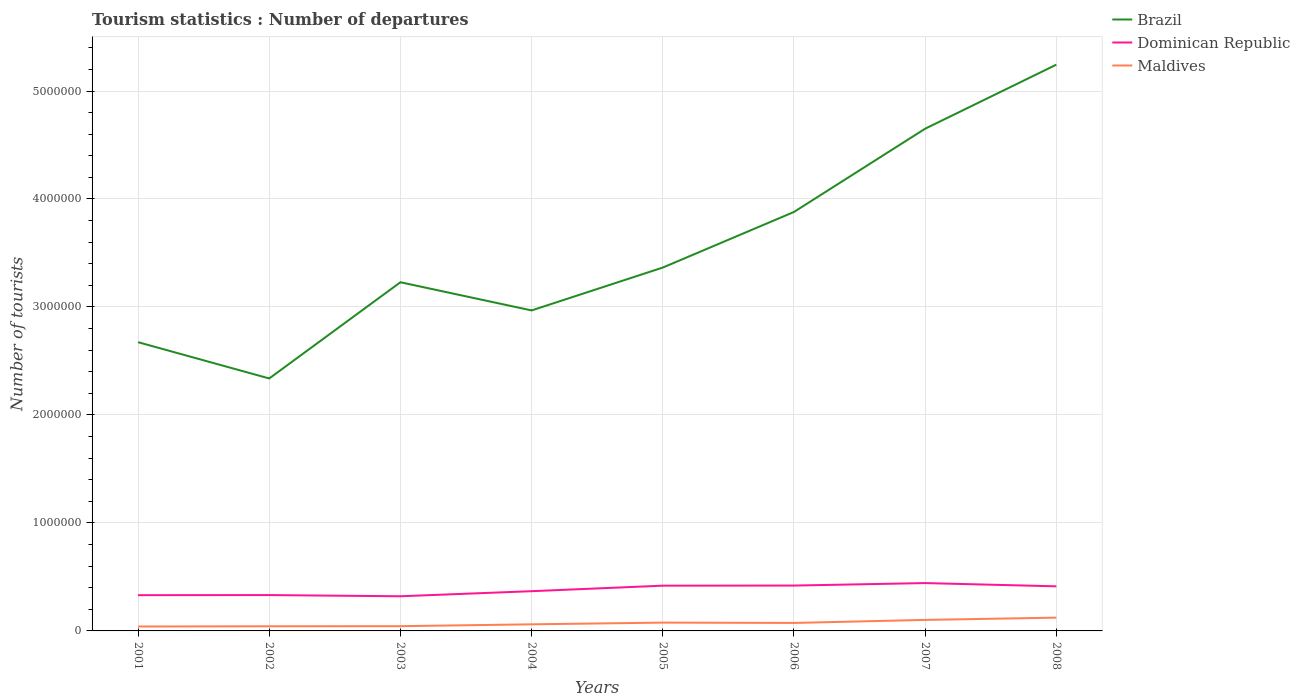Across all years, what is the maximum number of tourist departures in Brazil?
Make the answer very short. 2.34e+06. What is the total number of tourist departures in Maldives in the graph?
Offer a terse response. -5.80e+04. What is the difference between the highest and the second highest number of tourist departures in Dominican Republic?
Offer a terse response. 1.22e+05. What is the difference between the highest and the lowest number of tourist departures in Dominican Republic?
Offer a very short reply. 4. How many lines are there?
Offer a terse response. 3. How many years are there in the graph?
Your answer should be very brief. 8. Where does the legend appear in the graph?
Make the answer very short. Top right. How many legend labels are there?
Keep it short and to the point. 3. What is the title of the graph?
Your response must be concise. Tourism statistics : Number of departures. Does "Mozambique" appear as one of the legend labels in the graph?
Your answer should be compact. No. What is the label or title of the X-axis?
Your answer should be very brief. Years. What is the label or title of the Y-axis?
Give a very brief answer. Number of tourists. What is the Number of tourists in Brazil in 2001?
Offer a very short reply. 2.67e+06. What is the Number of tourists of Dominican Republic in 2001?
Ensure brevity in your answer.  3.31e+05. What is the Number of tourists in Maldives in 2001?
Make the answer very short. 4.10e+04. What is the Number of tourists in Brazil in 2002?
Your answer should be very brief. 2.34e+06. What is the Number of tourists in Dominican Republic in 2002?
Make the answer very short. 3.32e+05. What is the Number of tourists of Maldives in 2002?
Make the answer very short. 4.30e+04. What is the Number of tourists in Brazil in 2003?
Your response must be concise. 3.23e+06. What is the Number of tourists in Dominican Republic in 2003?
Offer a very short reply. 3.21e+05. What is the Number of tourists of Maldives in 2003?
Offer a terse response. 4.40e+04. What is the Number of tourists in Brazil in 2004?
Offer a terse response. 2.97e+06. What is the Number of tourists in Dominican Republic in 2004?
Your answer should be very brief. 3.68e+05. What is the Number of tourists in Maldives in 2004?
Provide a short and direct response. 6.10e+04. What is the Number of tourists of Brazil in 2005?
Your answer should be compact. 3.36e+06. What is the Number of tourists of Dominican Republic in 2005?
Your response must be concise. 4.19e+05. What is the Number of tourists in Maldives in 2005?
Offer a terse response. 7.70e+04. What is the Number of tourists in Brazil in 2006?
Offer a very short reply. 3.88e+06. What is the Number of tourists of Dominican Republic in 2006?
Make the answer very short. 4.20e+05. What is the Number of tourists of Maldives in 2006?
Keep it short and to the point. 7.40e+04. What is the Number of tourists in Brazil in 2007?
Ensure brevity in your answer.  4.65e+06. What is the Number of tourists in Dominican Republic in 2007?
Offer a very short reply. 4.43e+05. What is the Number of tourists of Maldives in 2007?
Offer a very short reply. 1.02e+05. What is the Number of tourists in Brazil in 2008?
Your answer should be compact. 5.24e+06. What is the Number of tourists of Dominican Republic in 2008?
Ensure brevity in your answer.  4.13e+05. What is the Number of tourists in Maldives in 2008?
Provide a succinct answer. 1.23e+05. Across all years, what is the maximum Number of tourists of Brazil?
Offer a terse response. 5.24e+06. Across all years, what is the maximum Number of tourists of Dominican Republic?
Your answer should be compact. 4.43e+05. Across all years, what is the maximum Number of tourists of Maldives?
Make the answer very short. 1.23e+05. Across all years, what is the minimum Number of tourists of Brazil?
Keep it short and to the point. 2.34e+06. Across all years, what is the minimum Number of tourists of Dominican Republic?
Make the answer very short. 3.21e+05. Across all years, what is the minimum Number of tourists of Maldives?
Offer a terse response. 4.10e+04. What is the total Number of tourists in Brazil in the graph?
Ensure brevity in your answer.  2.83e+07. What is the total Number of tourists of Dominican Republic in the graph?
Ensure brevity in your answer.  3.05e+06. What is the total Number of tourists of Maldives in the graph?
Your answer should be compact. 5.65e+05. What is the difference between the Number of tourists in Brazil in 2001 and that in 2002?
Ensure brevity in your answer.  3.36e+05. What is the difference between the Number of tourists in Dominican Republic in 2001 and that in 2002?
Give a very brief answer. -1000. What is the difference between the Number of tourists of Maldives in 2001 and that in 2002?
Ensure brevity in your answer.  -2000. What is the difference between the Number of tourists in Brazil in 2001 and that in 2003?
Keep it short and to the point. -5.55e+05. What is the difference between the Number of tourists of Dominican Republic in 2001 and that in 2003?
Provide a succinct answer. 10000. What is the difference between the Number of tourists of Maldives in 2001 and that in 2003?
Offer a very short reply. -3000. What is the difference between the Number of tourists of Brazil in 2001 and that in 2004?
Ensure brevity in your answer.  -2.94e+05. What is the difference between the Number of tourists in Dominican Republic in 2001 and that in 2004?
Your answer should be compact. -3.70e+04. What is the difference between the Number of tourists in Maldives in 2001 and that in 2004?
Keep it short and to the point. -2.00e+04. What is the difference between the Number of tourists in Brazil in 2001 and that in 2005?
Your answer should be very brief. -6.91e+05. What is the difference between the Number of tourists of Dominican Republic in 2001 and that in 2005?
Provide a short and direct response. -8.80e+04. What is the difference between the Number of tourists of Maldives in 2001 and that in 2005?
Provide a short and direct response. -3.60e+04. What is the difference between the Number of tourists in Brazil in 2001 and that in 2006?
Ensure brevity in your answer.  -1.21e+06. What is the difference between the Number of tourists in Dominican Republic in 2001 and that in 2006?
Offer a very short reply. -8.90e+04. What is the difference between the Number of tourists in Maldives in 2001 and that in 2006?
Your answer should be compact. -3.30e+04. What is the difference between the Number of tourists of Brazil in 2001 and that in 2007?
Make the answer very short. -1.98e+06. What is the difference between the Number of tourists of Dominican Republic in 2001 and that in 2007?
Your answer should be very brief. -1.12e+05. What is the difference between the Number of tourists of Maldives in 2001 and that in 2007?
Provide a succinct answer. -6.10e+04. What is the difference between the Number of tourists of Brazil in 2001 and that in 2008?
Provide a short and direct response. -2.57e+06. What is the difference between the Number of tourists of Dominican Republic in 2001 and that in 2008?
Make the answer very short. -8.20e+04. What is the difference between the Number of tourists of Maldives in 2001 and that in 2008?
Your answer should be compact. -8.20e+04. What is the difference between the Number of tourists in Brazil in 2002 and that in 2003?
Give a very brief answer. -8.91e+05. What is the difference between the Number of tourists in Dominican Republic in 2002 and that in 2003?
Keep it short and to the point. 1.10e+04. What is the difference between the Number of tourists of Maldives in 2002 and that in 2003?
Provide a short and direct response. -1000. What is the difference between the Number of tourists of Brazil in 2002 and that in 2004?
Provide a short and direct response. -6.30e+05. What is the difference between the Number of tourists in Dominican Republic in 2002 and that in 2004?
Your answer should be very brief. -3.60e+04. What is the difference between the Number of tourists in Maldives in 2002 and that in 2004?
Your response must be concise. -1.80e+04. What is the difference between the Number of tourists in Brazil in 2002 and that in 2005?
Make the answer very short. -1.03e+06. What is the difference between the Number of tourists in Dominican Republic in 2002 and that in 2005?
Provide a succinct answer. -8.70e+04. What is the difference between the Number of tourists in Maldives in 2002 and that in 2005?
Provide a succinct answer. -3.40e+04. What is the difference between the Number of tourists in Brazil in 2002 and that in 2006?
Provide a succinct answer. -1.54e+06. What is the difference between the Number of tourists in Dominican Republic in 2002 and that in 2006?
Your answer should be compact. -8.80e+04. What is the difference between the Number of tourists in Maldives in 2002 and that in 2006?
Keep it short and to the point. -3.10e+04. What is the difference between the Number of tourists of Brazil in 2002 and that in 2007?
Your answer should be very brief. -2.31e+06. What is the difference between the Number of tourists in Dominican Republic in 2002 and that in 2007?
Keep it short and to the point. -1.11e+05. What is the difference between the Number of tourists in Maldives in 2002 and that in 2007?
Offer a terse response. -5.90e+04. What is the difference between the Number of tourists in Brazil in 2002 and that in 2008?
Your answer should be very brief. -2.91e+06. What is the difference between the Number of tourists of Dominican Republic in 2002 and that in 2008?
Offer a very short reply. -8.10e+04. What is the difference between the Number of tourists of Maldives in 2002 and that in 2008?
Your answer should be very brief. -8.00e+04. What is the difference between the Number of tourists in Brazil in 2003 and that in 2004?
Your answer should be compact. 2.61e+05. What is the difference between the Number of tourists of Dominican Republic in 2003 and that in 2004?
Keep it short and to the point. -4.70e+04. What is the difference between the Number of tourists of Maldives in 2003 and that in 2004?
Offer a very short reply. -1.70e+04. What is the difference between the Number of tourists in Brazil in 2003 and that in 2005?
Ensure brevity in your answer.  -1.36e+05. What is the difference between the Number of tourists in Dominican Republic in 2003 and that in 2005?
Provide a succinct answer. -9.80e+04. What is the difference between the Number of tourists of Maldives in 2003 and that in 2005?
Keep it short and to the point. -3.30e+04. What is the difference between the Number of tourists of Brazil in 2003 and that in 2006?
Your response must be concise. -6.51e+05. What is the difference between the Number of tourists in Dominican Republic in 2003 and that in 2006?
Your answer should be very brief. -9.90e+04. What is the difference between the Number of tourists in Brazil in 2003 and that in 2007?
Offer a terse response. -1.42e+06. What is the difference between the Number of tourists in Dominican Republic in 2003 and that in 2007?
Keep it short and to the point. -1.22e+05. What is the difference between the Number of tourists in Maldives in 2003 and that in 2007?
Keep it short and to the point. -5.80e+04. What is the difference between the Number of tourists in Brazil in 2003 and that in 2008?
Provide a short and direct response. -2.02e+06. What is the difference between the Number of tourists of Dominican Republic in 2003 and that in 2008?
Provide a succinct answer. -9.20e+04. What is the difference between the Number of tourists in Maldives in 2003 and that in 2008?
Keep it short and to the point. -7.90e+04. What is the difference between the Number of tourists of Brazil in 2004 and that in 2005?
Provide a succinct answer. -3.97e+05. What is the difference between the Number of tourists in Dominican Republic in 2004 and that in 2005?
Provide a succinct answer. -5.10e+04. What is the difference between the Number of tourists in Maldives in 2004 and that in 2005?
Keep it short and to the point. -1.60e+04. What is the difference between the Number of tourists in Brazil in 2004 and that in 2006?
Ensure brevity in your answer.  -9.12e+05. What is the difference between the Number of tourists in Dominican Republic in 2004 and that in 2006?
Offer a terse response. -5.20e+04. What is the difference between the Number of tourists in Maldives in 2004 and that in 2006?
Provide a short and direct response. -1.30e+04. What is the difference between the Number of tourists in Brazil in 2004 and that in 2007?
Your answer should be compact. -1.68e+06. What is the difference between the Number of tourists of Dominican Republic in 2004 and that in 2007?
Your answer should be compact. -7.50e+04. What is the difference between the Number of tourists in Maldives in 2004 and that in 2007?
Give a very brief answer. -4.10e+04. What is the difference between the Number of tourists in Brazil in 2004 and that in 2008?
Your response must be concise. -2.28e+06. What is the difference between the Number of tourists of Dominican Republic in 2004 and that in 2008?
Your response must be concise. -4.50e+04. What is the difference between the Number of tourists in Maldives in 2004 and that in 2008?
Your answer should be compact. -6.20e+04. What is the difference between the Number of tourists in Brazil in 2005 and that in 2006?
Ensure brevity in your answer.  -5.15e+05. What is the difference between the Number of tourists of Dominican Republic in 2005 and that in 2006?
Ensure brevity in your answer.  -1000. What is the difference between the Number of tourists of Maldives in 2005 and that in 2006?
Make the answer very short. 3000. What is the difference between the Number of tourists of Brazil in 2005 and that in 2007?
Offer a very short reply. -1.29e+06. What is the difference between the Number of tourists of Dominican Republic in 2005 and that in 2007?
Your answer should be compact. -2.40e+04. What is the difference between the Number of tourists of Maldives in 2005 and that in 2007?
Your answer should be very brief. -2.50e+04. What is the difference between the Number of tourists of Brazil in 2005 and that in 2008?
Offer a very short reply. -1.88e+06. What is the difference between the Number of tourists in Dominican Republic in 2005 and that in 2008?
Make the answer very short. 6000. What is the difference between the Number of tourists in Maldives in 2005 and that in 2008?
Keep it short and to the point. -4.60e+04. What is the difference between the Number of tourists of Brazil in 2006 and that in 2007?
Ensure brevity in your answer.  -7.71e+05. What is the difference between the Number of tourists of Dominican Republic in 2006 and that in 2007?
Make the answer very short. -2.30e+04. What is the difference between the Number of tourists in Maldives in 2006 and that in 2007?
Your answer should be very brief. -2.80e+04. What is the difference between the Number of tourists of Brazil in 2006 and that in 2008?
Keep it short and to the point. -1.36e+06. What is the difference between the Number of tourists in Dominican Republic in 2006 and that in 2008?
Offer a very short reply. 7000. What is the difference between the Number of tourists of Maldives in 2006 and that in 2008?
Provide a short and direct response. -4.90e+04. What is the difference between the Number of tourists in Brazil in 2007 and that in 2008?
Your answer should be compact. -5.93e+05. What is the difference between the Number of tourists in Maldives in 2007 and that in 2008?
Ensure brevity in your answer.  -2.10e+04. What is the difference between the Number of tourists of Brazil in 2001 and the Number of tourists of Dominican Republic in 2002?
Offer a very short reply. 2.34e+06. What is the difference between the Number of tourists in Brazil in 2001 and the Number of tourists in Maldives in 2002?
Ensure brevity in your answer.  2.63e+06. What is the difference between the Number of tourists in Dominican Republic in 2001 and the Number of tourists in Maldives in 2002?
Offer a very short reply. 2.88e+05. What is the difference between the Number of tourists in Brazil in 2001 and the Number of tourists in Dominican Republic in 2003?
Your response must be concise. 2.35e+06. What is the difference between the Number of tourists of Brazil in 2001 and the Number of tourists of Maldives in 2003?
Your answer should be very brief. 2.63e+06. What is the difference between the Number of tourists of Dominican Republic in 2001 and the Number of tourists of Maldives in 2003?
Offer a very short reply. 2.87e+05. What is the difference between the Number of tourists of Brazil in 2001 and the Number of tourists of Dominican Republic in 2004?
Give a very brief answer. 2.31e+06. What is the difference between the Number of tourists in Brazil in 2001 and the Number of tourists in Maldives in 2004?
Your answer should be very brief. 2.61e+06. What is the difference between the Number of tourists in Brazil in 2001 and the Number of tourists in Dominican Republic in 2005?
Your response must be concise. 2.26e+06. What is the difference between the Number of tourists in Brazil in 2001 and the Number of tourists in Maldives in 2005?
Provide a succinct answer. 2.60e+06. What is the difference between the Number of tourists in Dominican Republic in 2001 and the Number of tourists in Maldives in 2005?
Your answer should be very brief. 2.54e+05. What is the difference between the Number of tourists in Brazil in 2001 and the Number of tourists in Dominican Republic in 2006?
Make the answer very short. 2.25e+06. What is the difference between the Number of tourists in Brazil in 2001 and the Number of tourists in Maldives in 2006?
Ensure brevity in your answer.  2.60e+06. What is the difference between the Number of tourists of Dominican Republic in 2001 and the Number of tourists of Maldives in 2006?
Provide a short and direct response. 2.57e+05. What is the difference between the Number of tourists in Brazil in 2001 and the Number of tourists in Dominican Republic in 2007?
Give a very brief answer. 2.23e+06. What is the difference between the Number of tourists of Brazil in 2001 and the Number of tourists of Maldives in 2007?
Your response must be concise. 2.57e+06. What is the difference between the Number of tourists in Dominican Republic in 2001 and the Number of tourists in Maldives in 2007?
Offer a very short reply. 2.29e+05. What is the difference between the Number of tourists in Brazil in 2001 and the Number of tourists in Dominican Republic in 2008?
Make the answer very short. 2.26e+06. What is the difference between the Number of tourists of Brazil in 2001 and the Number of tourists of Maldives in 2008?
Offer a terse response. 2.55e+06. What is the difference between the Number of tourists in Dominican Republic in 2001 and the Number of tourists in Maldives in 2008?
Provide a short and direct response. 2.08e+05. What is the difference between the Number of tourists in Brazil in 2002 and the Number of tourists in Dominican Republic in 2003?
Your answer should be very brief. 2.02e+06. What is the difference between the Number of tourists in Brazil in 2002 and the Number of tourists in Maldives in 2003?
Your answer should be compact. 2.29e+06. What is the difference between the Number of tourists of Dominican Republic in 2002 and the Number of tourists of Maldives in 2003?
Offer a terse response. 2.88e+05. What is the difference between the Number of tourists in Brazil in 2002 and the Number of tourists in Dominican Republic in 2004?
Make the answer very short. 1.97e+06. What is the difference between the Number of tourists in Brazil in 2002 and the Number of tourists in Maldives in 2004?
Make the answer very short. 2.28e+06. What is the difference between the Number of tourists of Dominican Republic in 2002 and the Number of tourists of Maldives in 2004?
Make the answer very short. 2.71e+05. What is the difference between the Number of tourists of Brazil in 2002 and the Number of tourists of Dominican Republic in 2005?
Provide a succinct answer. 1.92e+06. What is the difference between the Number of tourists in Brazil in 2002 and the Number of tourists in Maldives in 2005?
Make the answer very short. 2.26e+06. What is the difference between the Number of tourists in Dominican Republic in 2002 and the Number of tourists in Maldives in 2005?
Make the answer very short. 2.55e+05. What is the difference between the Number of tourists of Brazil in 2002 and the Number of tourists of Dominican Republic in 2006?
Your response must be concise. 1.92e+06. What is the difference between the Number of tourists of Brazil in 2002 and the Number of tourists of Maldives in 2006?
Offer a very short reply. 2.26e+06. What is the difference between the Number of tourists in Dominican Republic in 2002 and the Number of tourists in Maldives in 2006?
Ensure brevity in your answer.  2.58e+05. What is the difference between the Number of tourists in Brazil in 2002 and the Number of tourists in Dominican Republic in 2007?
Offer a terse response. 1.90e+06. What is the difference between the Number of tourists in Brazil in 2002 and the Number of tourists in Maldives in 2007?
Your response must be concise. 2.24e+06. What is the difference between the Number of tourists in Dominican Republic in 2002 and the Number of tourists in Maldives in 2007?
Offer a very short reply. 2.30e+05. What is the difference between the Number of tourists of Brazil in 2002 and the Number of tourists of Dominican Republic in 2008?
Your answer should be very brief. 1.92e+06. What is the difference between the Number of tourists in Brazil in 2002 and the Number of tourists in Maldives in 2008?
Ensure brevity in your answer.  2.22e+06. What is the difference between the Number of tourists of Dominican Republic in 2002 and the Number of tourists of Maldives in 2008?
Give a very brief answer. 2.09e+05. What is the difference between the Number of tourists of Brazil in 2003 and the Number of tourists of Dominican Republic in 2004?
Give a very brief answer. 2.86e+06. What is the difference between the Number of tourists of Brazil in 2003 and the Number of tourists of Maldives in 2004?
Offer a terse response. 3.17e+06. What is the difference between the Number of tourists in Brazil in 2003 and the Number of tourists in Dominican Republic in 2005?
Ensure brevity in your answer.  2.81e+06. What is the difference between the Number of tourists of Brazil in 2003 and the Number of tourists of Maldives in 2005?
Provide a succinct answer. 3.15e+06. What is the difference between the Number of tourists of Dominican Republic in 2003 and the Number of tourists of Maldives in 2005?
Your response must be concise. 2.44e+05. What is the difference between the Number of tourists in Brazil in 2003 and the Number of tourists in Dominican Republic in 2006?
Provide a short and direct response. 2.81e+06. What is the difference between the Number of tourists of Brazil in 2003 and the Number of tourists of Maldives in 2006?
Keep it short and to the point. 3.16e+06. What is the difference between the Number of tourists of Dominican Republic in 2003 and the Number of tourists of Maldives in 2006?
Ensure brevity in your answer.  2.47e+05. What is the difference between the Number of tourists in Brazil in 2003 and the Number of tourists in Dominican Republic in 2007?
Offer a very short reply. 2.79e+06. What is the difference between the Number of tourists of Brazil in 2003 and the Number of tourists of Maldives in 2007?
Provide a succinct answer. 3.13e+06. What is the difference between the Number of tourists of Dominican Republic in 2003 and the Number of tourists of Maldives in 2007?
Give a very brief answer. 2.19e+05. What is the difference between the Number of tourists of Brazil in 2003 and the Number of tourists of Dominican Republic in 2008?
Your response must be concise. 2.82e+06. What is the difference between the Number of tourists of Brazil in 2003 and the Number of tourists of Maldives in 2008?
Give a very brief answer. 3.11e+06. What is the difference between the Number of tourists of Dominican Republic in 2003 and the Number of tourists of Maldives in 2008?
Provide a succinct answer. 1.98e+05. What is the difference between the Number of tourists in Brazil in 2004 and the Number of tourists in Dominican Republic in 2005?
Provide a short and direct response. 2.55e+06. What is the difference between the Number of tourists of Brazil in 2004 and the Number of tourists of Maldives in 2005?
Offer a very short reply. 2.89e+06. What is the difference between the Number of tourists of Dominican Republic in 2004 and the Number of tourists of Maldives in 2005?
Your response must be concise. 2.91e+05. What is the difference between the Number of tourists in Brazil in 2004 and the Number of tourists in Dominican Republic in 2006?
Give a very brief answer. 2.55e+06. What is the difference between the Number of tourists of Brazil in 2004 and the Number of tourists of Maldives in 2006?
Provide a succinct answer. 2.89e+06. What is the difference between the Number of tourists of Dominican Republic in 2004 and the Number of tourists of Maldives in 2006?
Your answer should be very brief. 2.94e+05. What is the difference between the Number of tourists of Brazil in 2004 and the Number of tourists of Dominican Republic in 2007?
Provide a short and direct response. 2.52e+06. What is the difference between the Number of tourists of Brazil in 2004 and the Number of tourists of Maldives in 2007?
Ensure brevity in your answer.  2.87e+06. What is the difference between the Number of tourists in Dominican Republic in 2004 and the Number of tourists in Maldives in 2007?
Your answer should be compact. 2.66e+05. What is the difference between the Number of tourists of Brazil in 2004 and the Number of tourists of Dominican Republic in 2008?
Your response must be concise. 2.56e+06. What is the difference between the Number of tourists of Brazil in 2004 and the Number of tourists of Maldives in 2008?
Make the answer very short. 2.84e+06. What is the difference between the Number of tourists of Dominican Republic in 2004 and the Number of tourists of Maldives in 2008?
Your answer should be very brief. 2.45e+05. What is the difference between the Number of tourists of Brazil in 2005 and the Number of tourists of Dominican Republic in 2006?
Offer a terse response. 2.94e+06. What is the difference between the Number of tourists in Brazil in 2005 and the Number of tourists in Maldives in 2006?
Offer a very short reply. 3.29e+06. What is the difference between the Number of tourists of Dominican Republic in 2005 and the Number of tourists of Maldives in 2006?
Keep it short and to the point. 3.45e+05. What is the difference between the Number of tourists of Brazil in 2005 and the Number of tourists of Dominican Republic in 2007?
Provide a short and direct response. 2.92e+06. What is the difference between the Number of tourists in Brazil in 2005 and the Number of tourists in Maldives in 2007?
Your answer should be compact. 3.26e+06. What is the difference between the Number of tourists in Dominican Republic in 2005 and the Number of tourists in Maldives in 2007?
Ensure brevity in your answer.  3.17e+05. What is the difference between the Number of tourists in Brazil in 2005 and the Number of tourists in Dominican Republic in 2008?
Make the answer very short. 2.95e+06. What is the difference between the Number of tourists of Brazil in 2005 and the Number of tourists of Maldives in 2008?
Your answer should be very brief. 3.24e+06. What is the difference between the Number of tourists of Dominican Republic in 2005 and the Number of tourists of Maldives in 2008?
Your answer should be compact. 2.96e+05. What is the difference between the Number of tourists of Brazil in 2006 and the Number of tourists of Dominican Republic in 2007?
Keep it short and to the point. 3.44e+06. What is the difference between the Number of tourists in Brazil in 2006 and the Number of tourists in Maldives in 2007?
Your response must be concise. 3.78e+06. What is the difference between the Number of tourists in Dominican Republic in 2006 and the Number of tourists in Maldives in 2007?
Provide a short and direct response. 3.18e+05. What is the difference between the Number of tourists of Brazil in 2006 and the Number of tourists of Dominican Republic in 2008?
Ensure brevity in your answer.  3.47e+06. What is the difference between the Number of tourists of Brazil in 2006 and the Number of tourists of Maldives in 2008?
Your answer should be very brief. 3.76e+06. What is the difference between the Number of tourists in Dominican Republic in 2006 and the Number of tourists in Maldives in 2008?
Your answer should be compact. 2.97e+05. What is the difference between the Number of tourists in Brazil in 2007 and the Number of tourists in Dominican Republic in 2008?
Ensure brevity in your answer.  4.24e+06. What is the difference between the Number of tourists of Brazil in 2007 and the Number of tourists of Maldives in 2008?
Keep it short and to the point. 4.53e+06. What is the difference between the Number of tourists in Dominican Republic in 2007 and the Number of tourists in Maldives in 2008?
Give a very brief answer. 3.20e+05. What is the average Number of tourists in Brazil per year?
Ensure brevity in your answer.  3.54e+06. What is the average Number of tourists of Dominican Republic per year?
Your answer should be very brief. 3.81e+05. What is the average Number of tourists in Maldives per year?
Your answer should be very brief. 7.06e+04. In the year 2001, what is the difference between the Number of tourists of Brazil and Number of tourists of Dominican Republic?
Provide a succinct answer. 2.34e+06. In the year 2001, what is the difference between the Number of tourists of Brazil and Number of tourists of Maldives?
Keep it short and to the point. 2.63e+06. In the year 2002, what is the difference between the Number of tourists in Brazil and Number of tourists in Dominican Republic?
Keep it short and to the point. 2.01e+06. In the year 2002, what is the difference between the Number of tourists in Brazil and Number of tourists in Maldives?
Make the answer very short. 2.30e+06. In the year 2002, what is the difference between the Number of tourists in Dominican Republic and Number of tourists in Maldives?
Offer a very short reply. 2.89e+05. In the year 2003, what is the difference between the Number of tourists of Brazil and Number of tourists of Dominican Republic?
Ensure brevity in your answer.  2.91e+06. In the year 2003, what is the difference between the Number of tourists in Brazil and Number of tourists in Maldives?
Make the answer very short. 3.18e+06. In the year 2003, what is the difference between the Number of tourists in Dominican Republic and Number of tourists in Maldives?
Make the answer very short. 2.77e+05. In the year 2004, what is the difference between the Number of tourists in Brazil and Number of tourists in Dominican Republic?
Provide a short and direct response. 2.60e+06. In the year 2004, what is the difference between the Number of tourists of Brazil and Number of tourists of Maldives?
Keep it short and to the point. 2.91e+06. In the year 2004, what is the difference between the Number of tourists of Dominican Republic and Number of tourists of Maldives?
Keep it short and to the point. 3.07e+05. In the year 2005, what is the difference between the Number of tourists in Brazil and Number of tourists in Dominican Republic?
Offer a very short reply. 2.95e+06. In the year 2005, what is the difference between the Number of tourists of Brazil and Number of tourists of Maldives?
Your answer should be very brief. 3.29e+06. In the year 2005, what is the difference between the Number of tourists in Dominican Republic and Number of tourists in Maldives?
Keep it short and to the point. 3.42e+05. In the year 2006, what is the difference between the Number of tourists of Brazil and Number of tourists of Dominican Republic?
Your response must be concise. 3.46e+06. In the year 2006, what is the difference between the Number of tourists in Brazil and Number of tourists in Maldives?
Give a very brief answer. 3.81e+06. In the year 2006, what is the difference between the Number of tourists of Dominican Republic and Number of tourists of Maldives?
Ensure brevity in your answer.  3.46e+05. In the year 2007, what is the difference between the Number of tourists of Brazil and Number of tourists of Dominican Republic?
Ensure brevity in your answer.  4.21e+06. In the year 2007, what is the difference between the Number of tourists in Brazil and Number of tourists in Maldives?
Your answer should be very brief. 4.55e+06. In the year 2007, what is the difference between the Number of tourists in Dominican Republic and Number of tourists in Maldives?
Provide a succinct answer. 3.41e+05. In the year 2008, what is the difference between the Number of tourists of Brazil and Number of tourists of Dominican Republic?
Keep it short and to the point. 4.83e+06. In the year 2008, what is the difference between the Number of tourists in Brazil and Number of tourists in Maldives?
Your answer should be compact. 5.12e+06. In the year 2008, what is the difference between the Number of tourists of Dominican Republic and Number of tourists of Maldives?
Provide a short and direct response. 2.90e+05. What is the ratio of the Number of tourists in Brazil in 2001 to that in 2002?
Offer a very short reply. 1.14. What is the ratio of the Number of tourists of Maldives in 2001 to that in 2002?
Provide a short and direct response. 0.95. What is the ratio of the Number of tourists of Brazil in 2001 to that in 2003?
Offer a terse response. 0.83. What is the ratio of the Number of tourists in Dominican Republic in 2001 to that in 2003?
Offer a terse response. 1.03. What is the ratio of the Number of tourists in Maldives in 2001 to that in 2003?
Your response must be concise. 0.93. What is the ratio of the Number of tourists in Brazil in 2001 to that in 2004?
Provide a short and direct response. 0.9. What is the ratio of the Number of tourists in Dominican Republic in 2001 to that in 2004?
Give a very brief answer. 0.9. What is the ratio of the Number of tourists in Maldives in 2001 to that in 2004?
Provide a succinct answer. 0.67. What is the ratio of the Number of tourists of Brazil in 2001 to that in 2005?
Offer a terse response. 0.79. What is the ratio of the Number of tourists in Dominican Republic in 2001 to that in 2005?
Make the answer very short. 0.79. What is the ratio of the Number of tourists in Maldives in 2001 to that in 2005?
Your answer should be compact. 0.53. What is the ratio of the Number of tourists in Brazil in 2001 to that in 2006?
Provide a succinct answer. 0.69. What is the ratio of the Number of tourists of Dominican Republic in 2001 to that in 2006?
Give a very brief answer. 0.79. What is the ratio of the Number of tourists in Maldives in 2001 to that in 2006?
Offer a very short reply. 0.55. What is the ratio of the Number of tourists in Brazil in 2001 to that in 2007?
Provide a succinct answer. 0.57. What is the ratio of the Number of tourists in Dominican Republic in 2001 to that in 2007?
Your answer should be compact. 0.75. What is the ratio of the Number of tourists of Maldives in 2001 to that in 2007?
Offer a very short reply. 0.4. What is the ratio of the Number of tourists of Brazil in 2001 to that in 2008?
Your response must be concise. 0.51. What is the ratio of the Number of tourists of Dominican Republic in 2001 to that in 2008?
Ensure brevity in your answer.  0.8. What is the ratio of the Number of tourists in Maldives in 2001 to that in 2008?
Your answer should be compact. 0.33. What is the ratio of the Number of tourists in Brazil in 2002 to that in 2003?
Give a very brief answer. 0.72. What is the ratio of the Number of tourists of Dominican Republic in 2002 to that in 2003?
Your answer should be very brief. 1.03. What is the ratio of the Number of tourists in Maldives in 2002 to that in 2003?
Offer a terse response. 0.98. What is the ratio of the Number of tourists in Brazil in 2002 to that in 2004?
Provide a succinct answer. 0.79. What is the ratio of the Number of tourists of Dominican Republic in 2002 to that in 2004?
Your response must be concise. 0.9. What is the ratio of the Number of tourists of Maldives in 2002 to that in 2004?
Provide a short and direct response. 0.7. What is the ratio of the Number of tourists of Brazil in 2002 to that in 2005?
Keep it short and to the point. 0.69. What is the ratio of the Number of tourists in Dominican Republic in 2002 to that in 2005?
Your response must be concise. 0.79. What is the ratio of the Number of tourists of Maldives in 2002 to that in 2005?
Provide a short and direct response. 0.56. What is the ratio of the Number of tourists in Brazil in 2002 to that in 2006?
Offer a terse response. 0.6. What is the ratio of the Number of tourists of Dominican Republic in 2002 to that in 2006?
Provide a short and direct response. 0.79. What is the ratio of the Number of tourists in Maldives in 2002 to that in 2006?
Provide a short and direct response. 0.58. What is the ratio of the Number of tourists of Brazil in 2002 to that in 2007?
Ensure brevity in your answer.  0.5. What is the ratio of the Number of tourists of Dominican Republic in 2002 to that in 2007?
Give a very brief answer. 0.75. What is the ratio of the Number of tourists of Maldives in 2002 to that in 2007?
Offer a terse response. 0.42. What is the ratio of the Number of tourists of Brazil in 2002 to that in 2008?
Your response must be concise. 0.45. What is the ratio of the Number of tourists of Dominican Republic in 2002 to that in 2008?
Make the answer very short. 0.8. What is the ratio of the Number of tourists in Maldives in 2002 to that in 2008?
Give a very brief answer. 0.35. What is the ratio of the Number of tourists in Brazil in 2003 to that in 2004?
Offer a terse response. 1.09. What is the ratio of the Number of tourists of Dominican Republic in 2003 to that in 2004?
Offer a terse response. 0.87. What is the ratio of the Number of tourists in Maldives in 2003 to that in 2004?
Provide a short and direct response. 0.72. What is the ratio of the Number of tourists of Brazil in 2003 to that in 2005?
Your answer should be compact. 0.96. What is the ratio of the Number of tourists of Dominican Republic in 2003 to that in 2005?
Give a very brief answer. 0.77. What is the ratio of the Number of tourists in Maldives in 2003 to that in 2005?
Give a very brief answer. 0.57. What is the ratio of the Number of tourists in Brazil in 2003 to that in 2006?
Offer a terse response. 0.83. What is the ratio of the Number of tourists of Dominican Republic in 2003 to that in 2006?
Ensure brevity in your answer.  0.76. What is the ratio of the Number of tourists of Maldives in 2003 to that in 2006?
Keep it short and to the point. 0.59. What is the ratio of the Number of tourists in Brazil in 2003 to that in 2007?
Your answer should be very brief. 0.69. What is the ratio of the Number of tourists in Dominican Republic in 2003 to that in 2007?
Give a very brief answer. 0.72. What is the ratio of the Number of tourists of Maldives in 2003 to that in 2007?
Keep it short and to the point. 0.43. What is the ratio of the Number of tourists of Brazil in 2003 to that in 2008?
Keep it short and to the point. 0.62. What is the ratio of the Number of tourists of Dominican Republic in 2003 to that in 2008?
Keep it short and to the point. 0.78. What is the ratio of the Number of tourists in Maldives in 2003 to that in 2008?
Offer a very short reply. 0.36. What is the ratio of the Number of tourists in Brazil in 2004 to that in 2005?
Make the answer very short. 0.88. What is the ratio of the Number of tourists of Dominican Republic in 2004 to that in 2005?
Your answer should be very brief. 0.88. What is the ratio of the Number of tourists in Maldives in 2004 to that in 2005?
Offer a terse response. 0.79. What is the ratio of the Number of tourists of Brazil in 2004 to that in 2006?
Ensure brevity in your answer.  0.76. What is the ratio of the Number of tourists of Dominican Republic in 2004 to that in 2006?
Your response must be concise. 0.88. What is the ratio of the Number of tourists in Maldives in 2004 to that in 2006?
Give a very brief answer. 0.82. What is the ratio of the Number of tourists in Brazil in 2004 to that in 2007?
Make the answer very short. 0.64. What is the ratio of the Number of tourists of Dominican Republic in 2004 to that in 2007?
Your answer should be compact. 0.83. What is the ratio of the Number of tourists of Maldives in 2004 to that in 2007?
Give a very brief answer. 0.6. What is the ratio of the Number of tourists of Brazil in 2004 to that in 2008?
Make the answer very short. 0.57. What is the ratio of the Number of tourists in Dominican Republic in 2004 to that in 2008?
Offer a very short reply. 0.89. What is the ratio of the Number of tourists of Maldives in 2004 to that in 2008?
Your answer should be very brief. 0.5. What is the ratio of the Number of tourists in Brazil in 2005 to that in 2006?
Your answer should be very brief. 0.87. What is the ratio of the Number of tourists of Dominican Republic in 2005 to that in 2006?
Keep it short and to the point. 1. What is the ratio of the Number of tourists in Maldives in 2005 to that in 2006?
Your answer should be very brief. 1.04. What is the ratio of the Number of tourists in Brazil in 2005 to that in 2007?
Keep it short and to the point. 0.72. What is the ratio of the Number of tourists of Dominican Republic in 2005 to that in 2007?
Give a very brief answer. 0.95. What is the ratio of the Number of tourists of Maldives in 2005 to that in 2007?
Provide a succinct answer. 0.75. What is the ratio of the Number of tourists of Brazil in 2005 to that in 2008?
Offer a terse response. 0.64. What is the ratio of the Number of tourists in Dominican Republic in 2005 to that in 2008?
Give a very brief answer. 1.01. What is the ratio of the Number of tourists of Maldives in 2005 to that in 2008?
Your answer should be very brief. 0.63. What is the ratio of the Number of tourists in Brazil in 2006 to that in 2007?
Provide a short and direct response. 0.83. What is the ratio of the Number of tourists in Dominican Republic in 2006 to that in 2007?
Offer a terse response. 0.95. What is the ratio of the Number of tourists in Maldives in 2006 to that in 2007?
Your response must be concise. 0.73. What is the ratio of the Number of tourists of Brazil in 2006 to that in 2008?
Your answer should be very brief. 0.74. What is the ratio of the Number of tourists in Dominican Republic in 2006 to that in 2008?
Your response must be concise. 1.02. What is the ratio of the Number of tourists in Maldives in 2006 to that in 2008?
Your answer should be very brief. 0.6. What is the ratio of the Number of tourists of Brazil in 2007 to that in 2008?
Your response must be concise. 0.89. What is the ratio of the Number of tourists of Dominican Republic in 2007 to that in 2008?
Keep it short and to the point. 1.07. What is the ratio of the Number of tourists in Maldives in 2007 to that in 2008?
Offer a terse response. 0.83. What is the difference between the highest and the second highest Number of tourists in Brazil?
Offer a very short reply. 5.93e+05. What is the difference between the highest and the second highest Number of tourists of Dominican Republic?
Ensure brevity in your answer.  2.30e+04. What is the difference between the highest and the second highest Number of tourists of Maldives?
Your answer should be compact. 2.10e+04. What is the difference between the highest and the lowest Number of tourists in Brazil?
Your response must be concise. 2.91e+06. What is the difference between the highest and the lowest Number of tourists of Dominican Republic?
Provide a succinct answer. 1.22e+05. What is the difference between the highest and the lowest Number of tourists of Maldives?
Provide a short and direct response. 8.20e+04. 